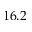Convert formula to latex. <formula><loc_0><loc_0><loc_500><loc_500>1 6 . 2</formula> 